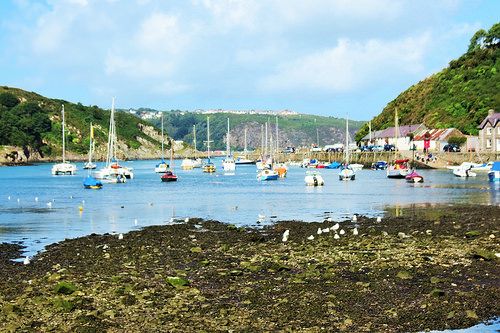<image>
Is there a water behind the mountain? Yes. From this viewpoint, the water is positioned behind the mountain, with the mountain partially or fully occluding the water. 